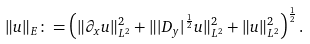Convert formula to latex. <formula><loc_0><loc_0><loc_500><loc_500>\| u \| _ { E } \colon = \left ( \| \partial _ { x } u \| _ { L ^ { 2 } } ^ { 2 } + \| | D _ { y } | ^ { \frac { 1 } { 2 } } u \| _ { L ^ { 2 } } ^ { 2 } + \| u \| _ { L ^ { 2 } } ^ { 2 } \right ) ^ { \frac { 1 } { 2 } } .</formula> 